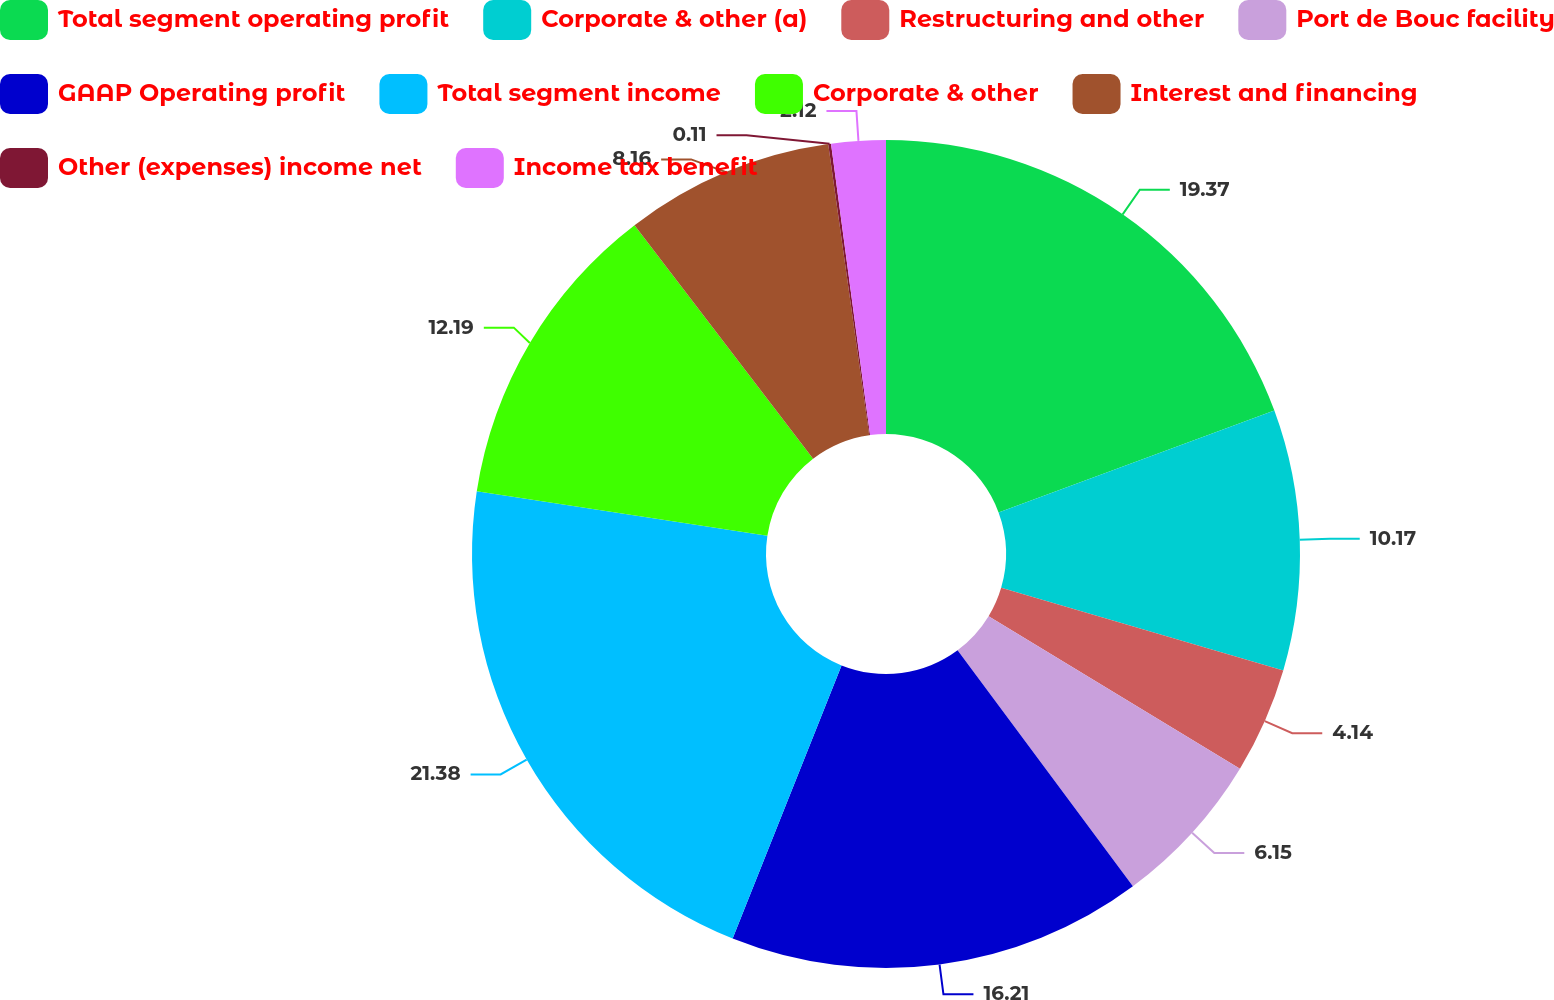<chart> <loc_0><loc_0><loc_500><loc_500><pie_chart><fcel>Total segment operating profit<fcel>Corporate & other (a)<fcel>Restructuring and other<fcel>Port de Bouc facility<fcel>GAAP Operating profit<fcel>Total segment income<fcel>Corporate & other<fcel>Interest and financing<fcel>Other (expenses) income net<fcel>Income tax benefit<nl><fcel>19.37%<fcel>10.17%<fcel>4.14%<fcel>6.15%<fcel>16.21%<fcel>21.38%<fcel>12.19%<fcel>8.16%<fcel>0.11%<fcel>2.12%<nl></chart> 